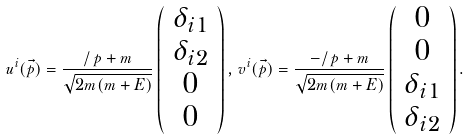<formula> <loc_0><loc_0><loc_500><loc_500>u ^ { i } ( \vec { p } ) = \frac { \slash \, p + m } { \sqrt { 2 m ( m + E ) } } \left ( \begin{array} { c } \delta _ { i 1 } \\ \delta _ { i 2 } \\ 0 \\ 0 \end{array} \right ) , \, v ^ { i } ( \vec { p } ) = \frac { - \slash \, p + m } { \sqrt { 2 m ( m + E ) } } \left ( \begin{array} { c } 0 \\ 0 \\ \delta _ { i 1 } \\ \delta _ { i 2 } \end{array} \right ) .</formula> 